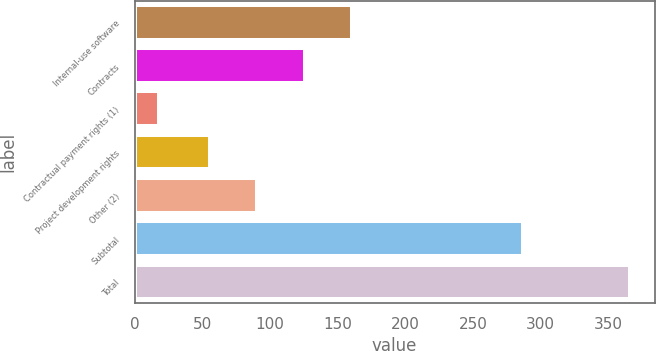Convert chart to OTSL. <chart><loc_0><loc_0><loc_500><loc_500><bar_chart><fcel>Internal-use software<fcel>Contracts<fcel>Contractual payment rights (1)<fcel>Project development rights<fcel>Other (2)<fcel>Subtotal<fcel>Total<nl><fcel>160.4<fcel>125.6<fcel>18<fcel>56<fcel>90.8<fcel>287<fcel>366<nl></chart> 